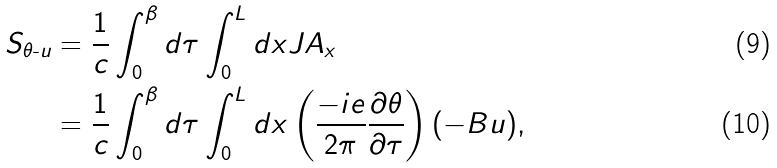<formula> <loc_0><loc_0><loc_500><loc_500>S _ { \theta \text {-} u } & = \frac { 1 } { c } \int _ { 0 } ^ { \beta } d \tau \int _ { 0 } ^ { L } d x J A _ { x } \\ & = \frac { 1 } { c } \int _ { 0 } ^ { \beta } d \tau \int _ { 0 } ^ { L } d x \left ( \frac { - i e } { 2 \pi } \frac { \partial \theta } { \partial \tau } \right ) ( - B u ) ,</formula> 